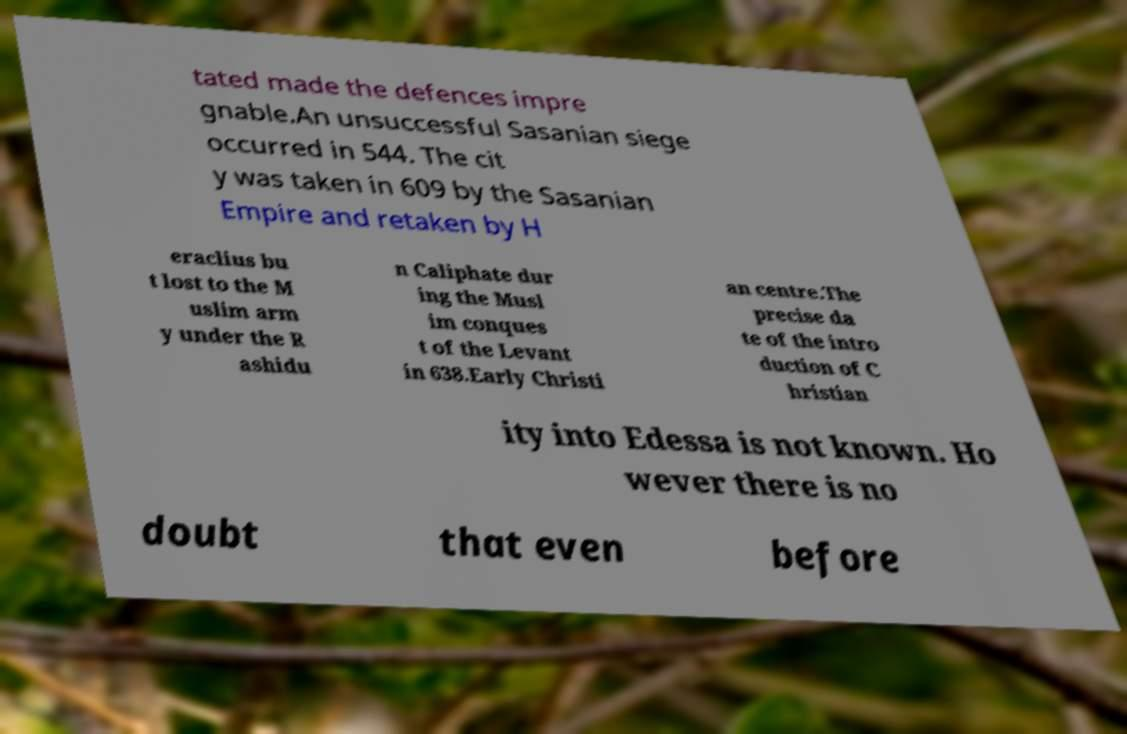Can you read and provide the text displayed in the image?This photo seems to have some interesting text. Can you extract and type it out for me? tated made the defences impre gnable.An unsuccessful Sasanian siege occurred in 544. The cit y was taken in 609 by the Sasanian Empire and retaken by H eraclius bu t lost to the M uslim arm y under the R ashidu n Caliphate dur ing the Musl im conques t of the Levant in 638.Early Christi an centre.The precise da te of the intro duction of C hristian ity into Edessa is not known. Ho wever there is no doubt that even before 